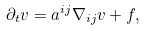<formula> <loc_0><loc_0><loc_500><loc_500>\partial _ { t } v = a ^ { i j } \nabla _ { i j } v + f ,</formula> 